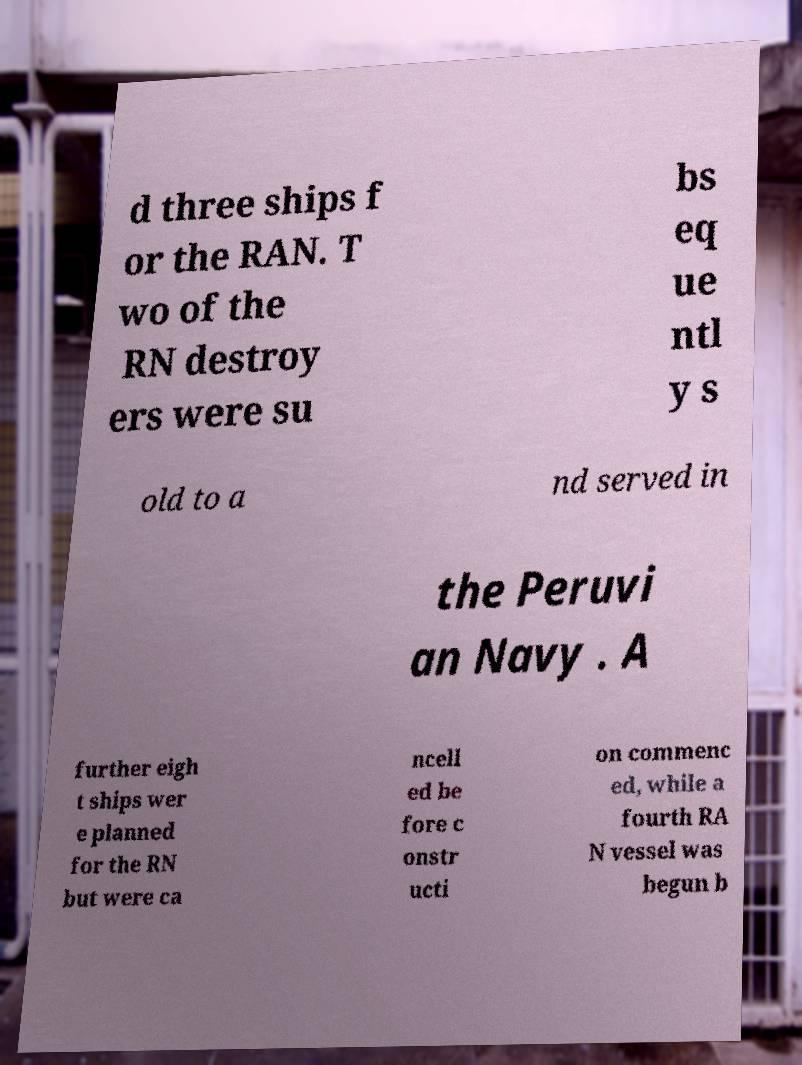I need the written content from this picture converted into text. Can you do that? d three ships f or the RAN. T wo of the RN destroy ers were su bs eq ue ntl y s old to a nd served in the Peruvi an Navy . A further eigh t ships wer e planned for the RN but were ca ncell ed be fore c onstr ucti on commenc ed, while a fourth RA N vessel was begun b 